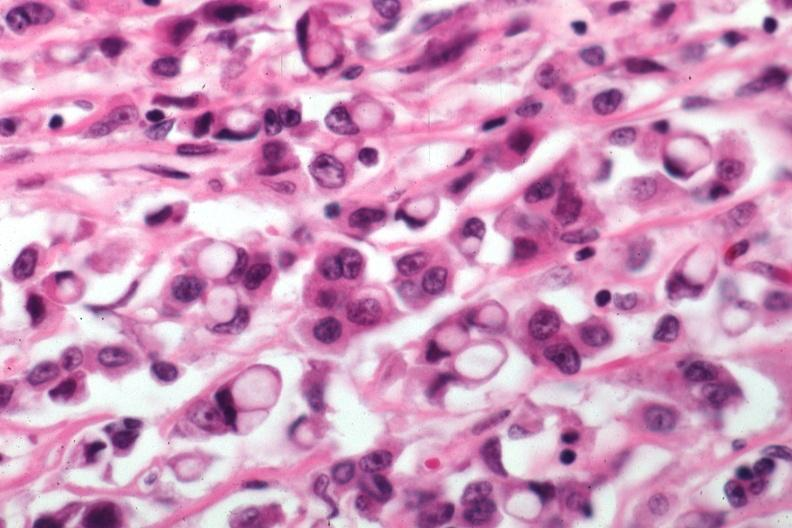what is present?
Answer the question using a single word or phrase. Carcinoma 